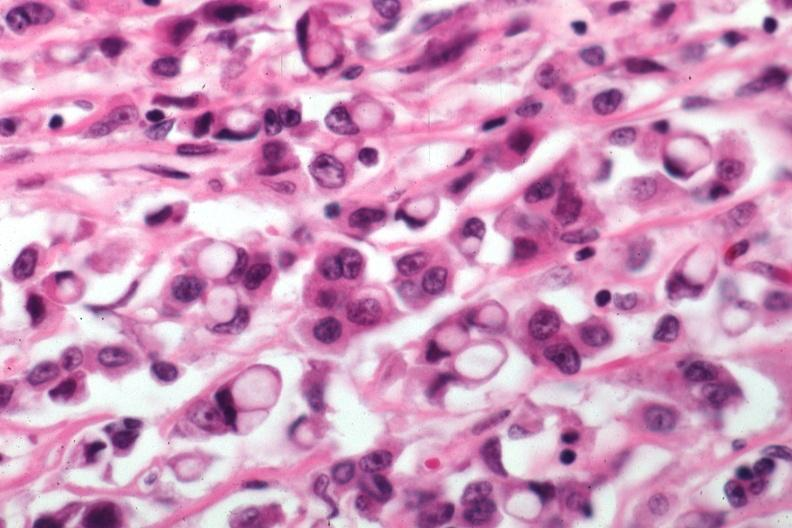what is present?
Answer the question using a single word or phrase. Carcinoma 